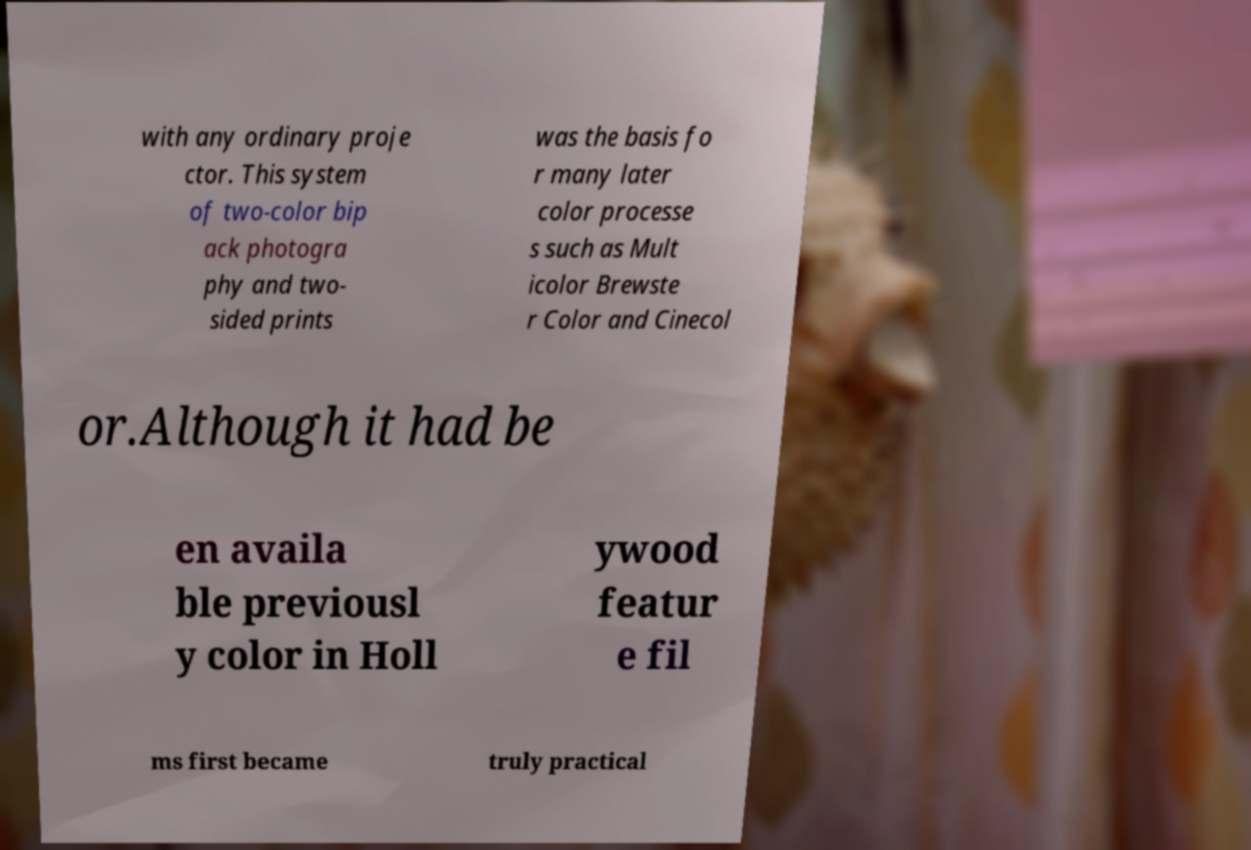What messages or text are displayed in this image? I need them in a readable, typed format. with any ordinary proje ctor. This system of two-color bip ack photogra phy and two- sided prints was the basis fo r many later color processe s such as Mult icolor Brewste r Color and Cinecol or.Although it had be en availa ble previousl y color in Holl ywood featur e fil ms first became truly practical 